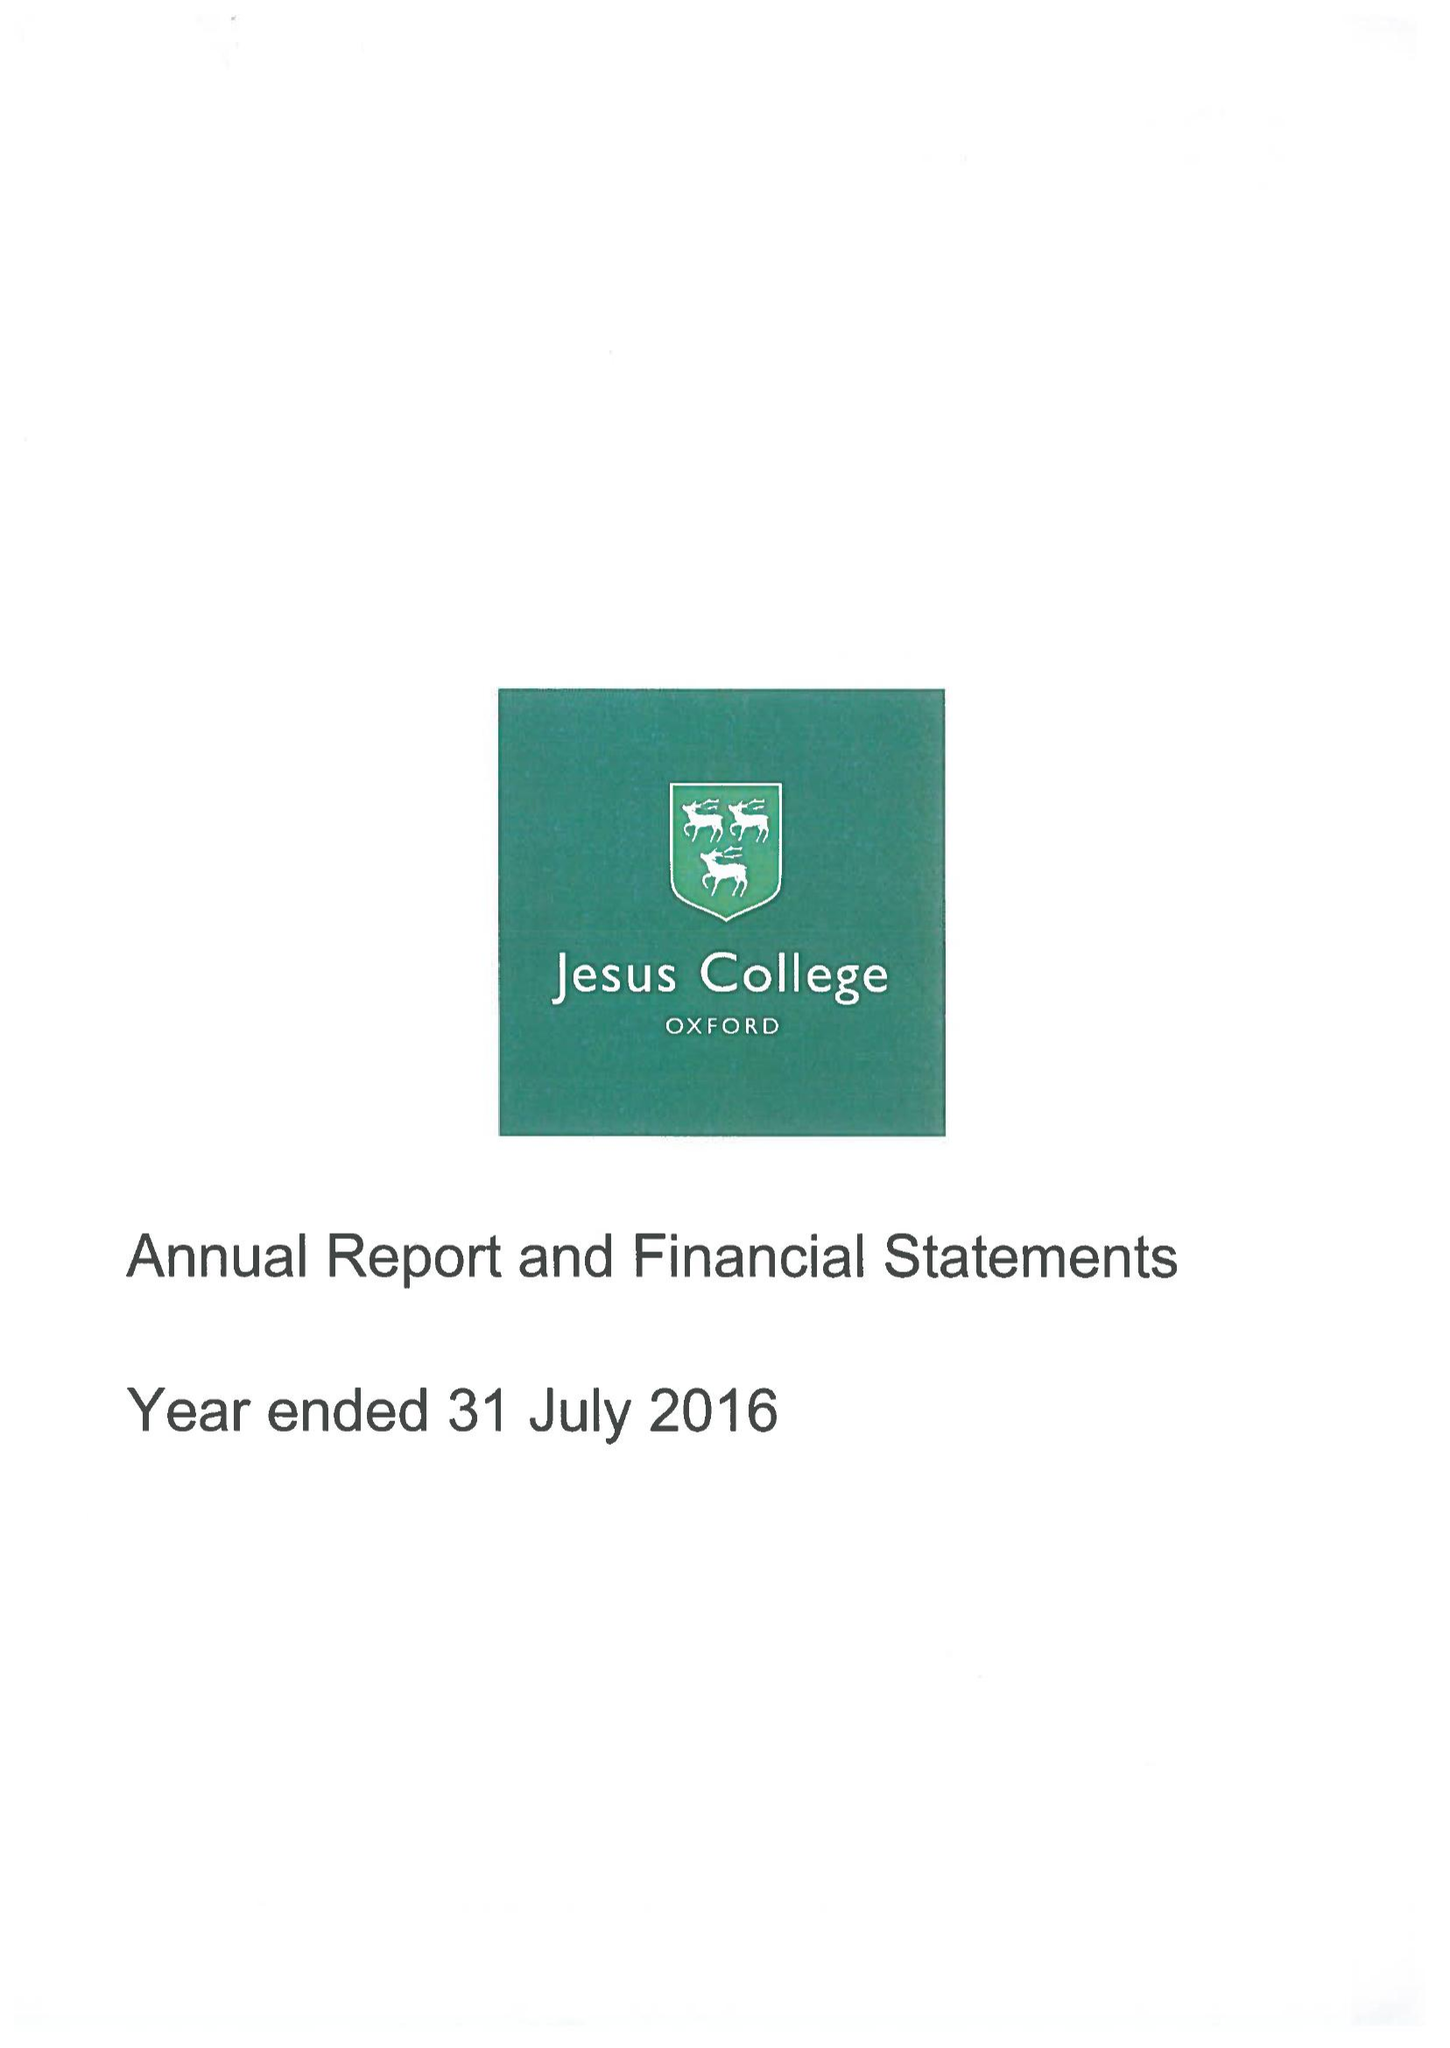What is the value for the income_annually_in_british_pounds?
Answer the question using a single word or phrase. 14238000.00 